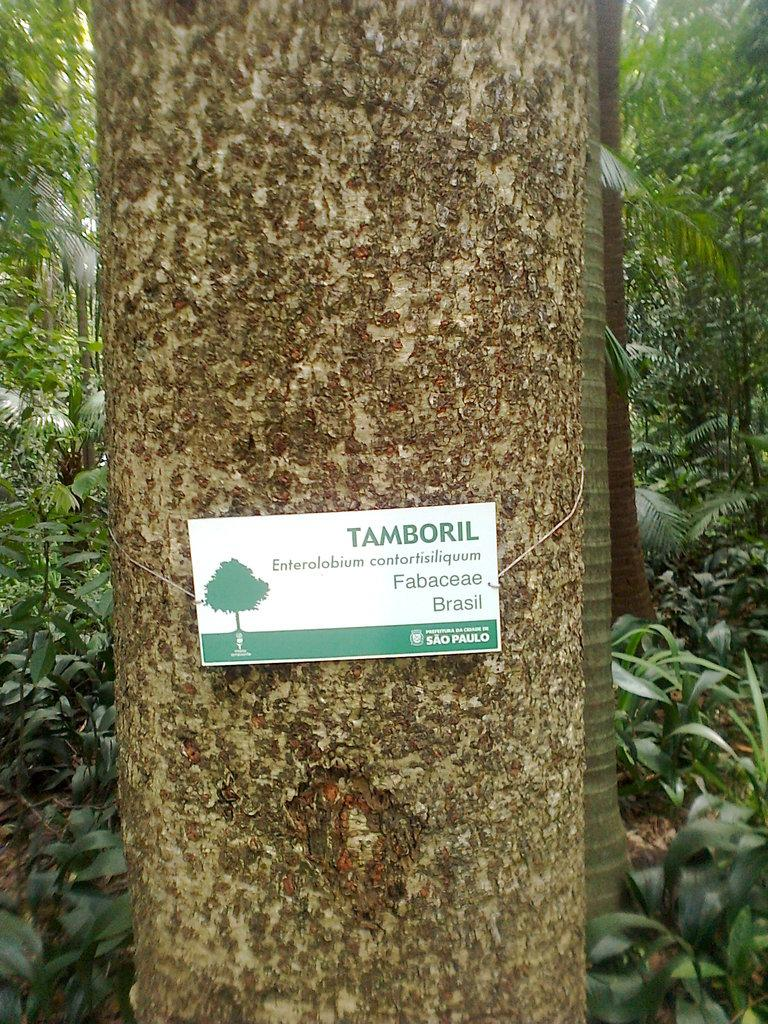What is attached to the trunk of a tree in the image? There is a card with text in the image. What type of vegetation is present in the image? There are trees and plants in the image. Can you describe the card's location in relation to the trees? The card is attached to the trunk of a tree. What effect does the pig have on the card in the image? There is no pig present in the image, so it cannot have any effect on the card. 